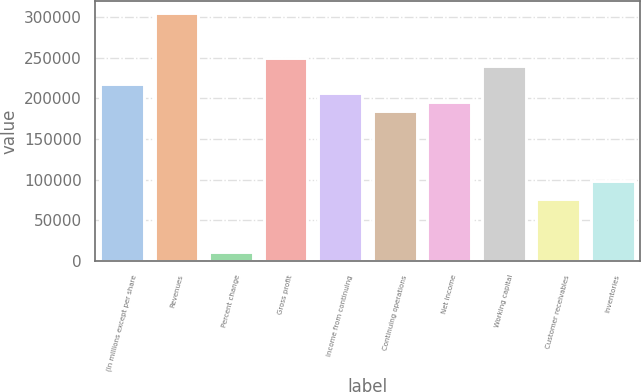Convert chart to OTSL. <chart><loc_0><loc_0><loc_500><loc_500><bar_chart><fcel>(In millions except per share<fcel>Revenues<fcel>Percent change<fcel>Gross profit<fcel>Income from continuing<fcel>Continuing operations<fcel>Net income<fcel>Working capital<fcel>Customer receivables<fcel>Inventories<nl><fcel>217403<fcel>304365<fcel>10870.6<fcel>250014<fcel>206533<fcel>184793<fcel>195663<fcel>239144<fcel>76091.5<fcel>97831.8<nl></chart> 